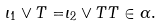<formula> <loc_0><loc_0><loc_500><loc_500>\iota _ { 1 } \vee T = & \iota _ { 2 } \vee T T \in \alpha .</formula> 